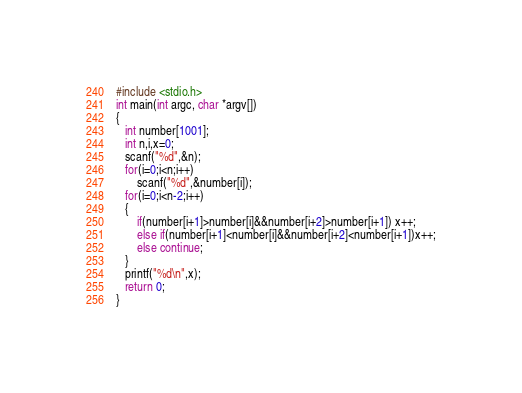Convert code to text. <code><loc_0><loc_0><loc_500><loc_500><_C_> #include <stdio.h>
 int main(int argc, char *argv[])
 {
    int number[1001];
    int n,i,x=0;
    scanf("%d",&n);
    for(i=0;i<n;i++)
        scanf("%d",&number[i]);
    for(i=0;i<n-2;i++)
    {
        if(number[i+1]>number[i]&&number[i+2]>number[i+1]) x++;
        else if(number[i+1]<number[i]&&number[i+2]<number[i+1])x++;
        else continue;
    }
    printf("%d\n",x);
    return 0;
 }</code> 